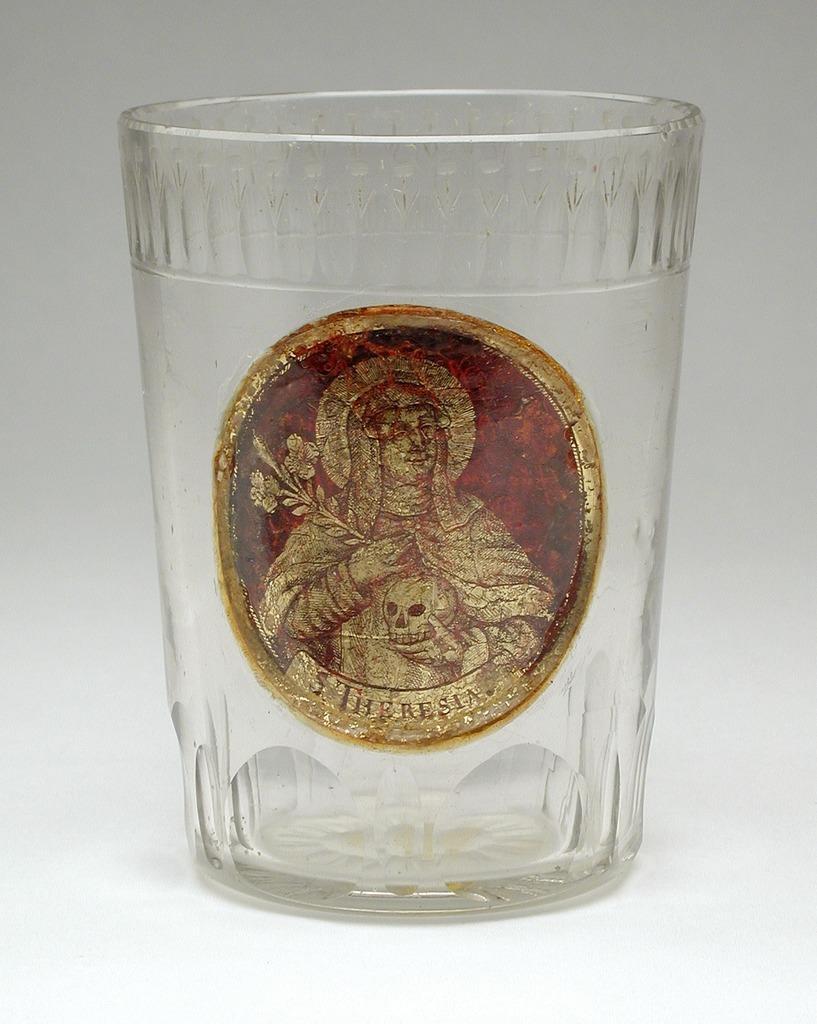Can you describe this image briefly? In this image there is a glass on the object, and there is a sticker of a person on the glass. 